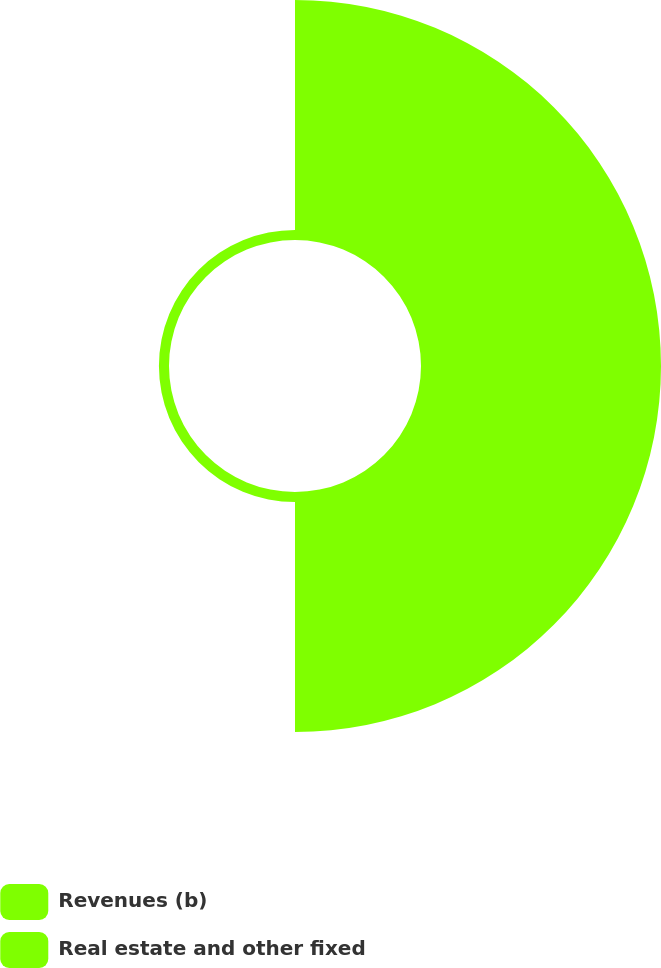Convert chart. <chart><loc_0><loc_0><loc_500><loc_500><pie_chart><fcel>Revenues (b)<fcel>Real estate and other fixed<nl><fcel>95.97%<fcel>4.03%<nl></chart> 